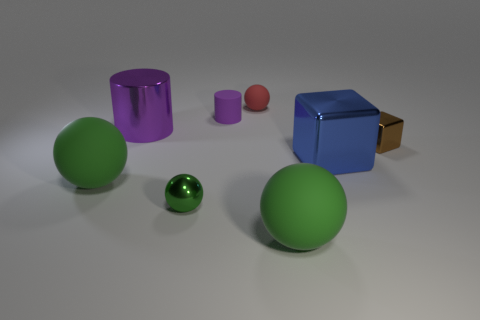There is another object that is the same shape as the brown thing; what is its material?
Provide a short and direct response. Metal. The large metal cylinder is what color?
Give a very brief answer. Purple. What color is the large ball that is on the left side of the green matte object right of the large purple shiny cylinder?
Provide a short and direct response. Green. Do the big cube and the large ball to the left of the red object have the same color?
Keep it short and to the point. No. There is a large shiny object right of the green metal object to the left of the small brown cube; how many shiny cubes are behind it?
Offer a terse response. 1. Are there any big things in front of the small shiny block?
Provide a succinct answer. Yes. Are there any other things that are the same color as the rubber cylinder?
Provide a succinct answer. Yes. What number of balls are either large green rubber things or small purple things?
Provide a short and direct response. 2. How many rubber balls are right of the small green object and in front of the small red rubber sphere?
Give a very brief answer. 1. Are there an equal number of big cylinders in front of the shiny cylinder and big blue things that are in front of the blue object?
Make the answer very short. Yes. 